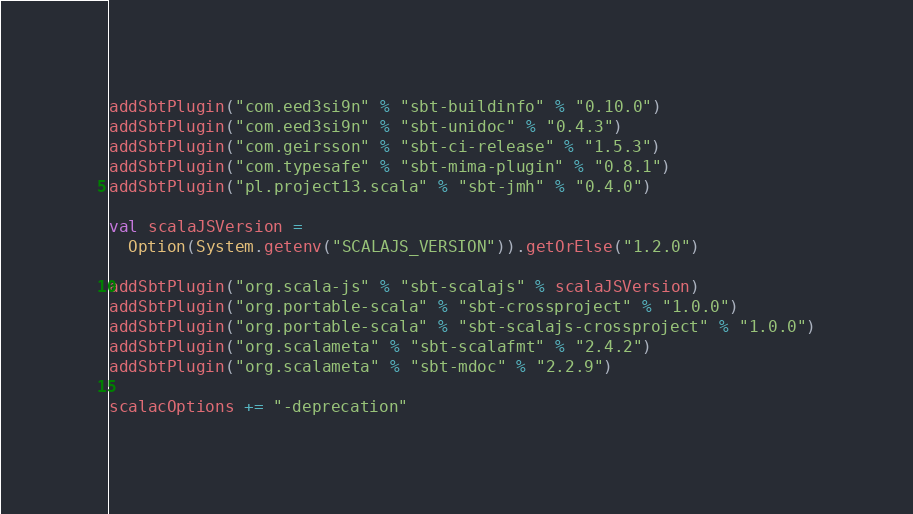<code> <loc_0><loc_0><loc_500><loc_500><_Scala_>addSbtPlugin("com.eed3si9n" % "sbt-buildinfo" % "0.10.0")
addSbtPlugin("com.eed3si9n" % "sbt-unidoc" % "0.4.3")
addSbtPlugin("com.geirsson" % "sbt-ci-release" % "1.5.3")
addSbtPlugin("com.typesafe" % "sbt-mima-plugin" % "0.8.1")
addSbtPlugin("pl.project13.scala" % "sbt-jmh" % "0.4.0")

val scalaJSVersion =
  Option(System.getenv("SCALAJS_VERSION")).getOrElse("1.2.0")

addSbtPlugin("org.scala-js" % "sbt-scalajs" % scalaJSVersion)
addSbtPlugin("org.portable-scala" % "sbt-crossproject" % "1.0.0")
addSbtPlugin("org.portable-scala" % "sbt-scalajs-crossproject" % "1.0.0")
addSbtPlugin("org.scalameta" % "sbt-scalafmt" % "2.4.2")
addSbtPlugin("org.scalameta" % "sbt-mdoc" % "2.2.9")

scalacOptions += "-deprecation"
</code> 